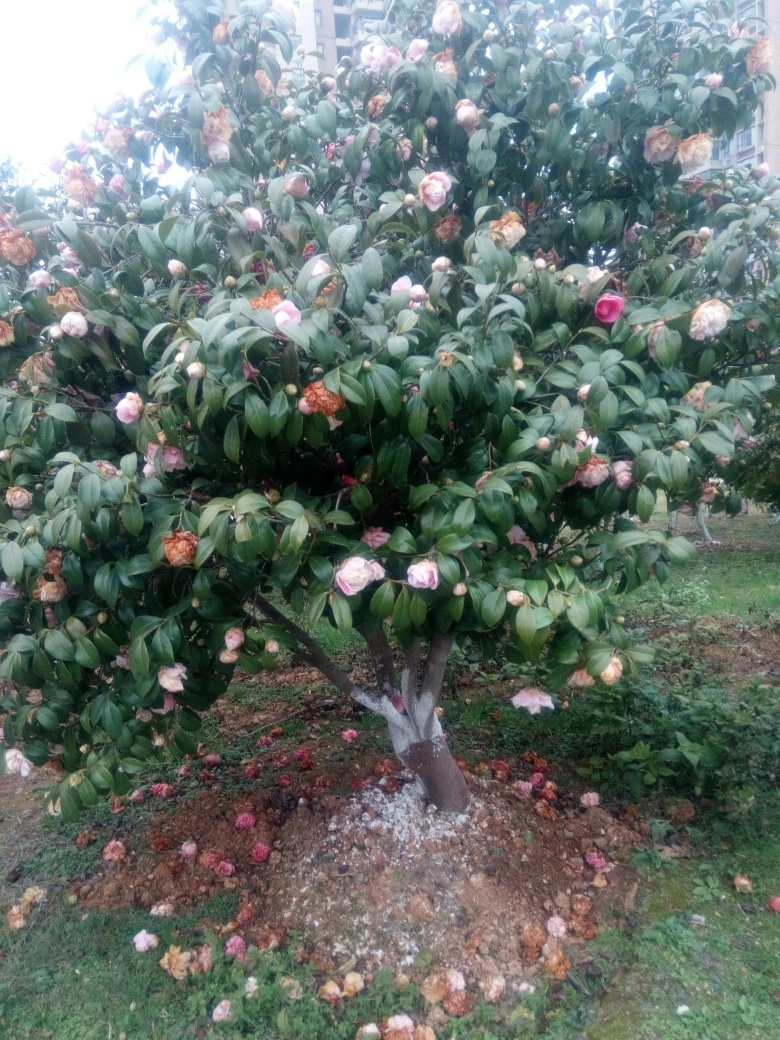Can you tell me what kind of tree this is? Based on the image, it appears to be a camellia tree, recognizable by its glossy green leaves and the distinctive form of its flowers. These plants are popular in ornamental gardens for their beautiful and varied blossoms. 